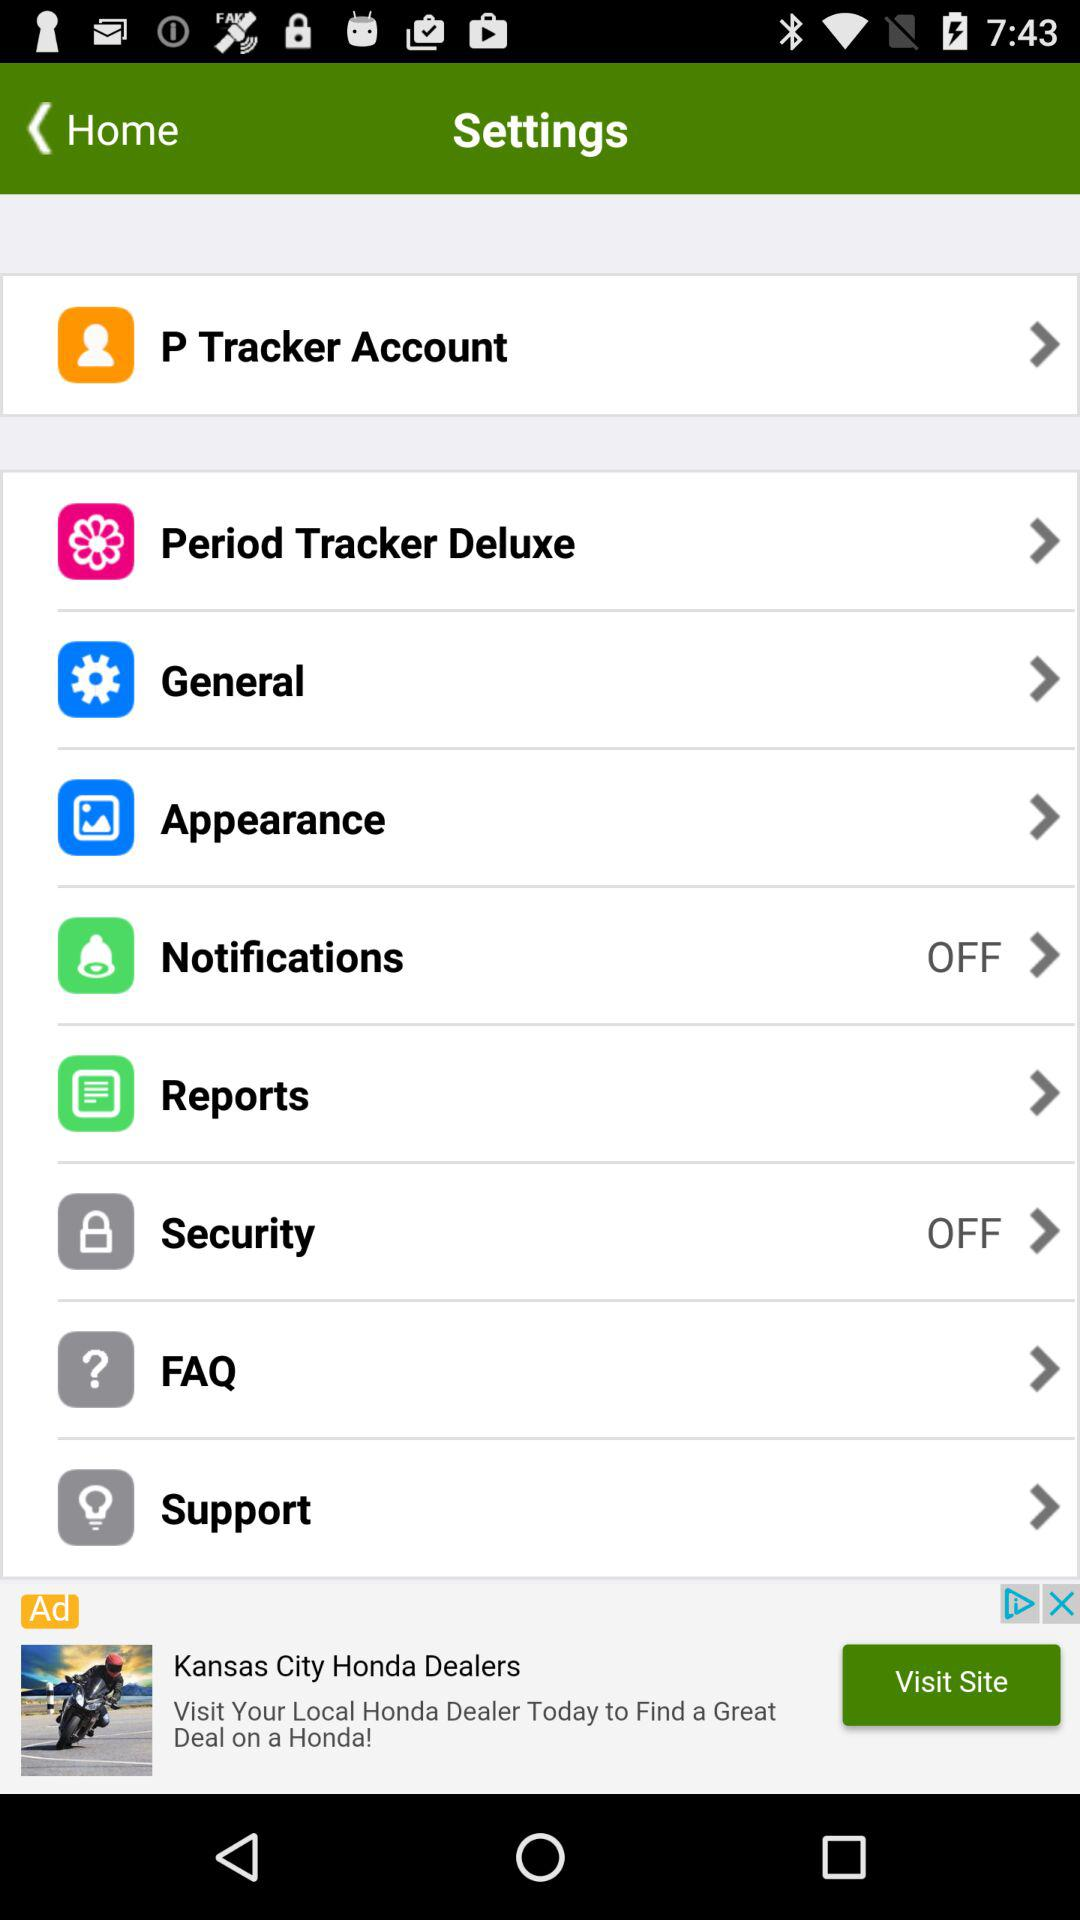How many items are disabled in the settings menu?
Answer the question using a single word or phrase. 2 